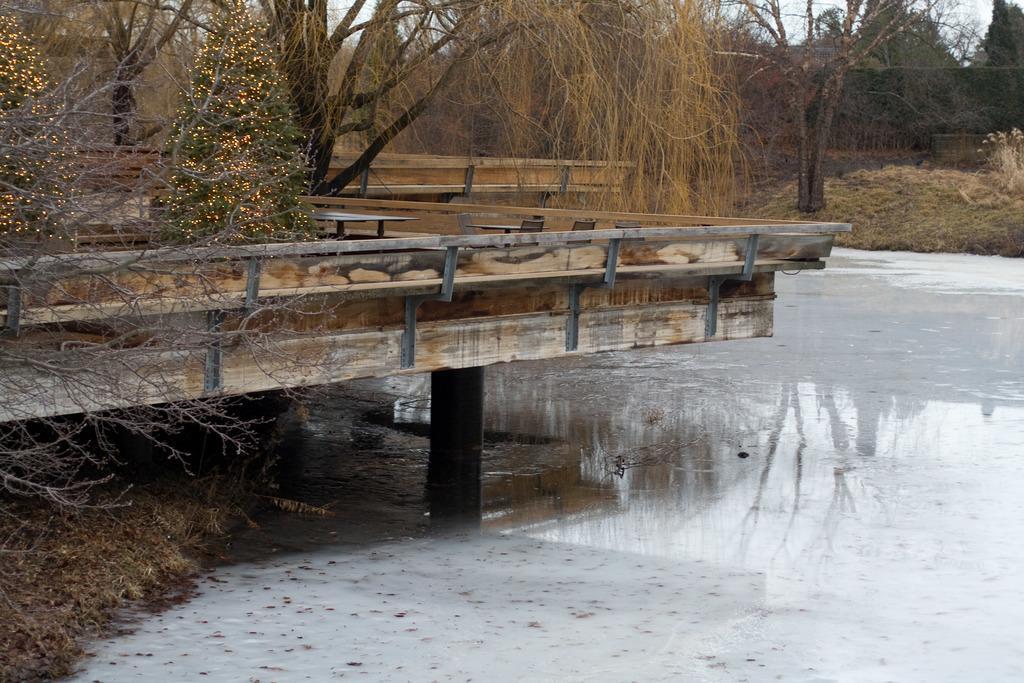In one or two sentences, can you explain what this image depicts? In this image, we can see some water. We can also see a wooden bridge above the water. There are a few trees and plants. We can also see some grass and the sky. We can see the reflection of trees in the water. 